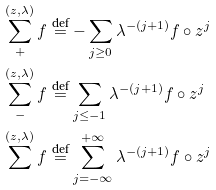<formula> <loc_0><loc_0><loc_500><loc_500>& \sum _ { + } ^ { ( z , \lambda ) } f \stackrel { \text {def} } { = } - \sum _ { j \geq 0 } \lambda ^ { - ( j + 1 ) } f \circ z ^ { j } \\ & \sum _ { - } ^ { ( z , \lambda ) } f \stackrel { \text {def} } { = } \sum _ { j \leq - 1 } \lambda ^ { - ( j + 1 ) } f \circ z ^ { j } \\ & \sum ^ { ( z , \lambda ) } f \stackrel { \text {def} } { = } \sum _ { j = - \infty } ^ { + \infty } \lambda ^ { - ( j + 1 ) } f \circ z ^ { j }</formula> 